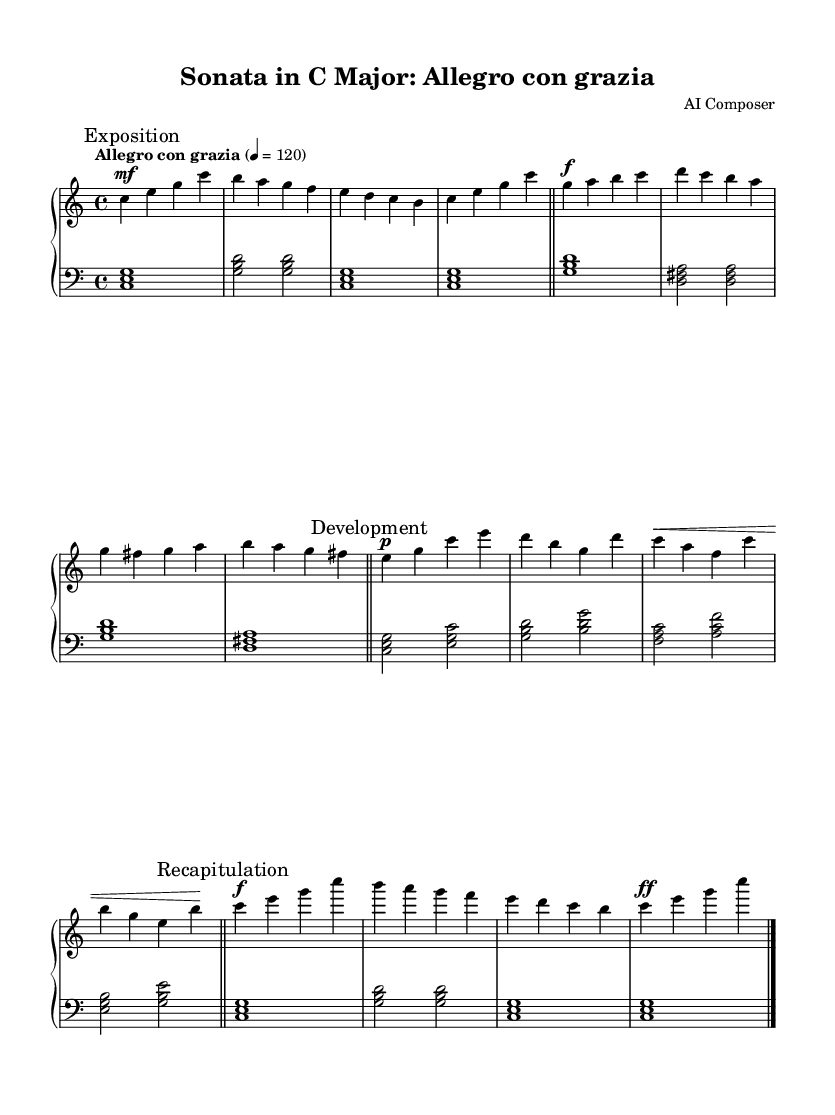What is the key signature of this music? The key signature is C major, which has no sharps or flats indicated in the music.
Answer: C major What is the time signature of this piece? The time signature is indicated at the beginning of the score as four beats per measure, shown by the notation 4/4.
Answer: 4/4 What is the tempo marking for this sonata? The tempo marking at the beginning specifies "Allegro con grazia", which indicates a lively tempo with gracefulness.
Answer: Allegro con grazia How many main sections are in this sonata? The music is divided into three main sections: Exposition, Development, and Recapitulation, which are clearly marked in the score.
Answer: Three In which section does the main theme first appear? The main theme first appears in the Exposition section, as indicated by the mark at the beginning of the music.
Answer: Exposition What dynamic marking is used for the secondary theme? The secondary theme begins with a forte marking, indicated by the "f" symbol, which suggests playing this section loudly.
Answer: Forte What is the function of the development section in classical sonatas? The development section often elaborates on themes introduced in the exposition and explores different harmonies and keys; in this case, it simplifies the themes while maintaining their essence.
Answer: Elaboration 